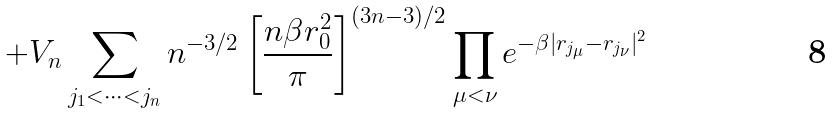Convert formula to latex. <formula><loc_0><loc_0><loc_500><loc_500>+ V _ { n } \sum _ { j _ { 1 } < \dots < j _ { n } } n ^ { - 3 / 2 } \left [ \frac { n \beta r _ { 0 } ^ { 2 } } { \pi } \right ] ^ { ( 3 n - 3 ) / 2 } \prod _ { \mu < \nu } e ^ { - \beta | { r } _ { j _ { \mu } } - { r } _ { j _ { \nu } } | ^ { 2 } }</formula> 